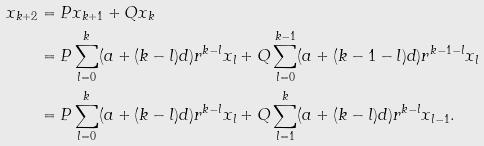<formula> <loc_0><loc_0><loc_500><loc_500>x _ { k + 2 } & = P x _ { k + 1 } + Q x _ { k } \\ & = P \sum _ { l = 0 } ^ { k } ( a + ( k - l ) d ) r ^ { k - l } x _ { l } + Q \sum _ { l = 0 } ^ { k - 1 } ( a + ( k - 1 - l ) d ) r ^ { k - 1 - l } x _ { l } \\ & = P \sum _ { l = 0 } ^ { k } ( a + ( k - l ) d ) r ^ { k - l } x _ { l } + Q \sum _ { l = 1 } ^ { k } ( a + ( k - l ) d ) r ^ { k - l } x _ { l - 1 } .</formula> 